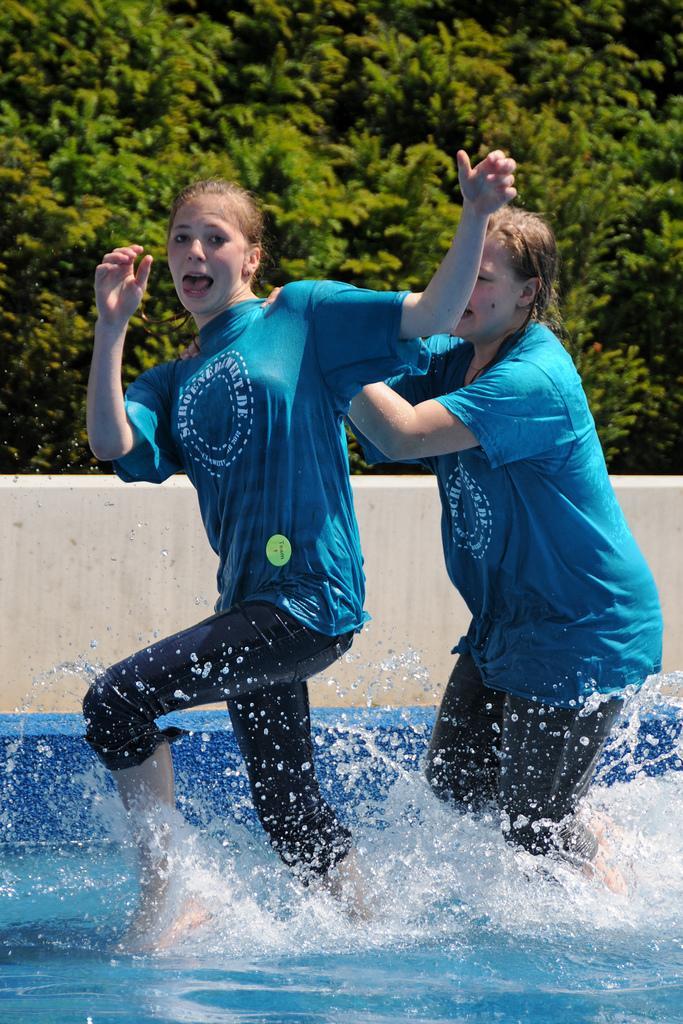Could you give a brief overview of what you see in this image? In this image I can see two women and I can see both of them are wearing same colour of dress. I can also see water and in background I can see few trees. I can also see something is written on their dresses. 